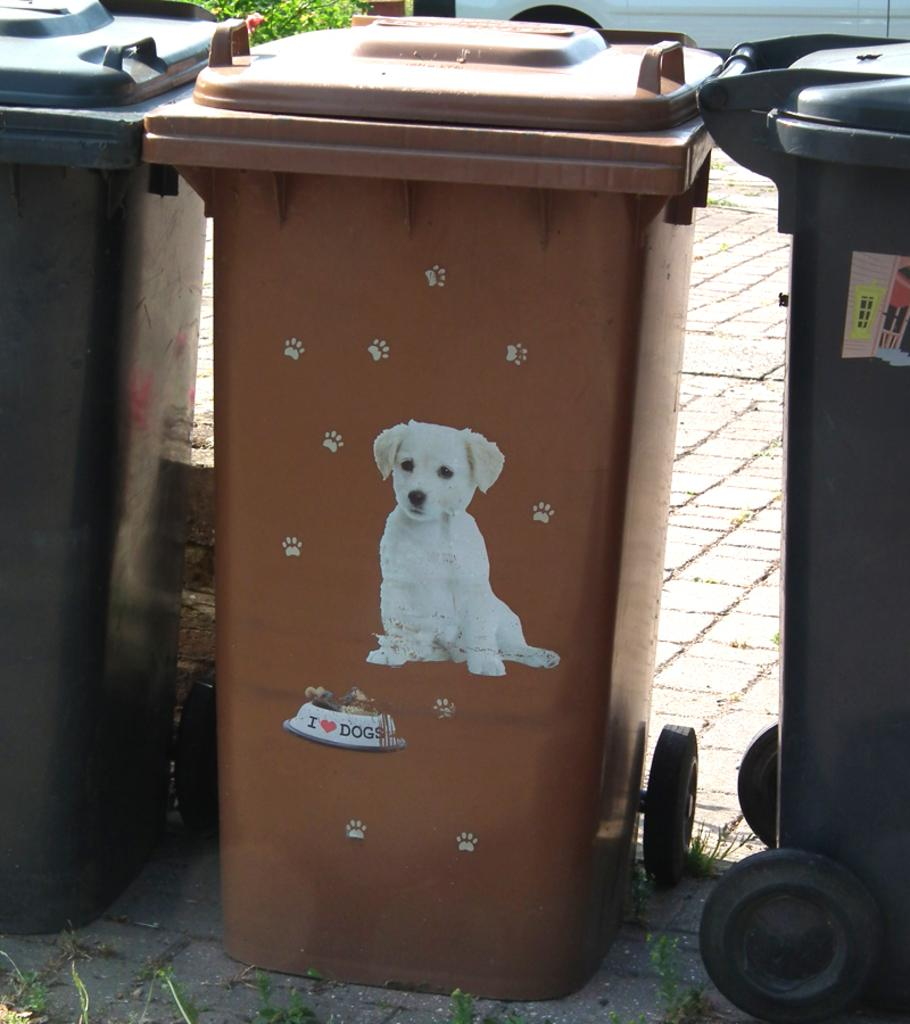<image>
Present a compact description of the photo's key features. A brown bin with a picture of a dog and dog bowl that says I Heart Dogs. 